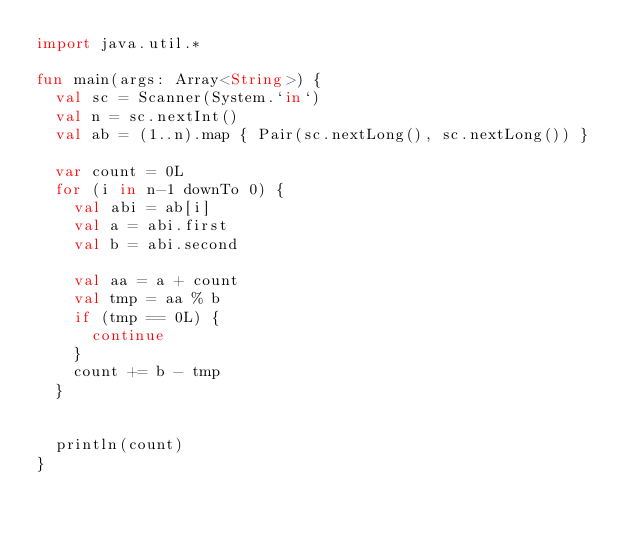<code> <loc_0><loc_0><loc_500><loc_500><_Kotlin_>import java.util.*

fun main(args: Array<String>) {
  val sc = Scanner(System.`in`)
  val n = sc.nextInt()
  val ab = (1..n).map { Pair(sc.nextLong(), sc.nextLong()) }

  var count = 0L
  for (i in n-1 downTo 0) {
    val abi = ab[i]
    val a = abi.first
    val b = abi.second

    val aa = a + count
    val tmp = aa % b
    if (tmp == 0L) {
      continue
    }
    count += b - tmp
  }


  println(count)
}
</code> 